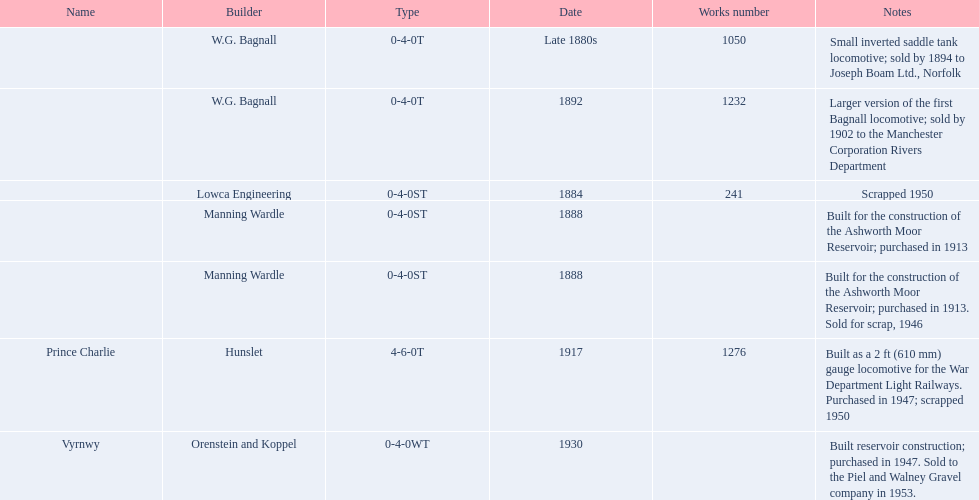How many train engines were constructed prior to the 1900s? 5. 